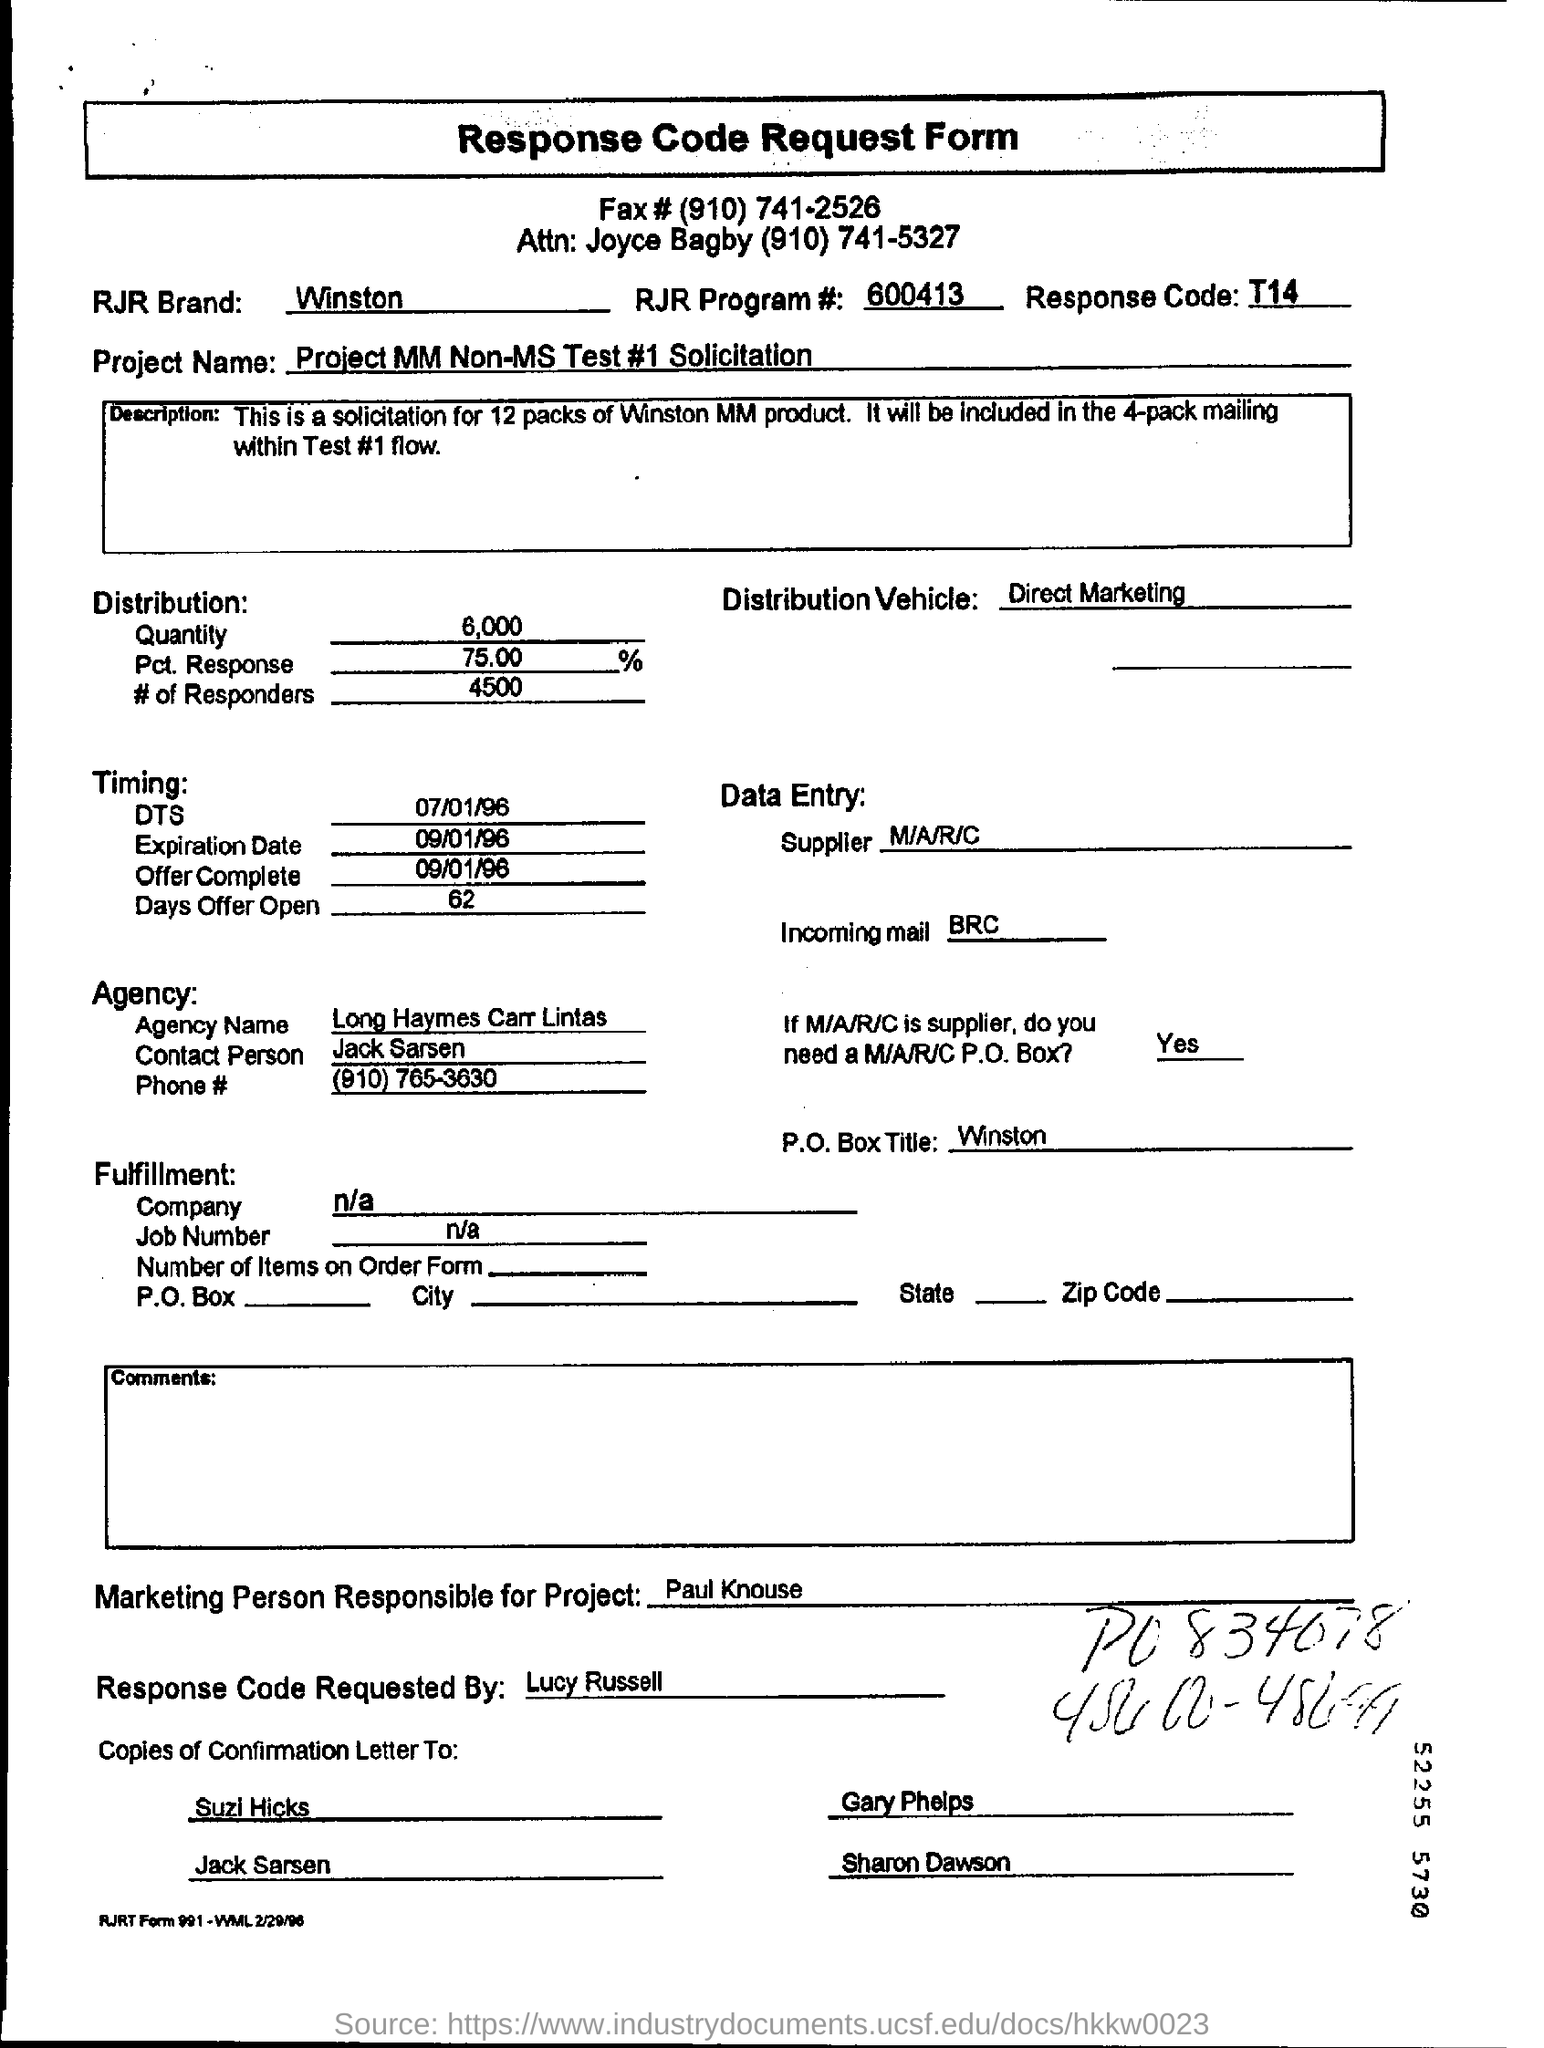What is the RJR brand mentioned on the response code request form?
Keep it short and to the point. Winston. What is RJR program number mentioned on the response code request form?
Keep it short and to the point. 600413. What is the response code?
Provide a short and direct response. T14. Who requested the response code request form?
Offer a very short reply. Lucy Russell. Who is the marketing person responsible for project?
Ensure brevity in your answer.  Paul knouse. Who is the contact person from the agency?
Provide a succinct answer. Jack Sarsen. 